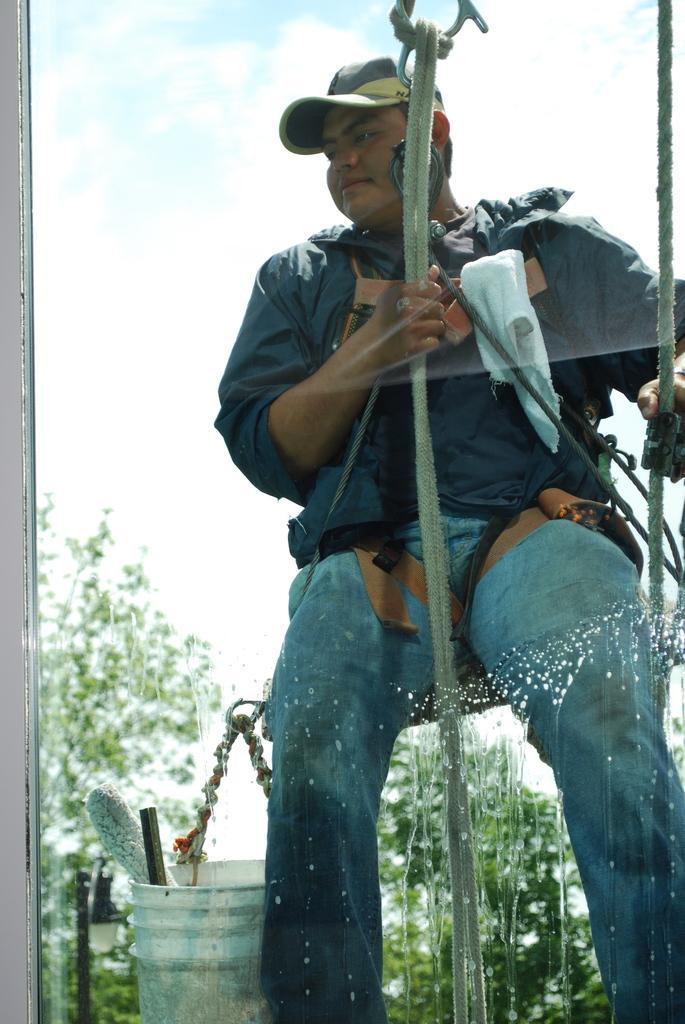Please provide a concise description of this image. In this image, we can see a man wearing a hat, he is hanging on the ropes, there is a white color bucket, in the background there are some green color trees, at the top there is a sky. 